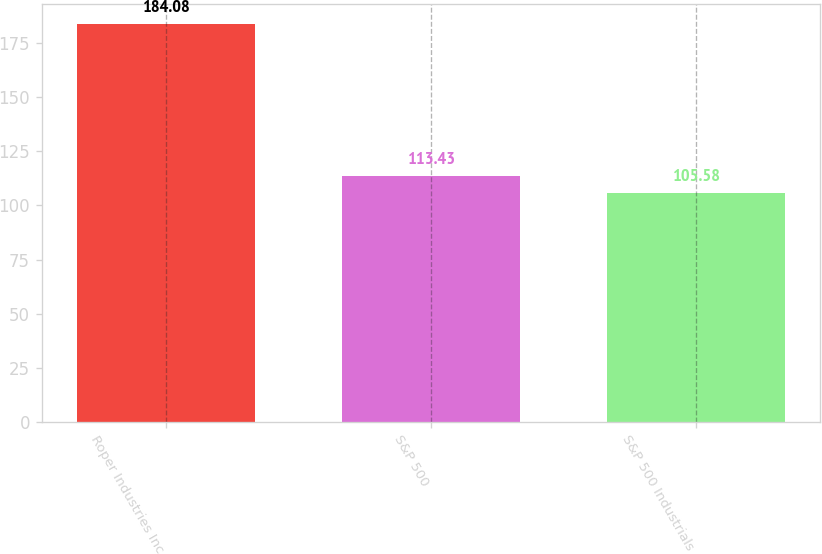Convert chart to OTSL. <chart><loc_0><loc_0><loc_500><loc_500><bar_chart><fcel>Roper Industries Inc<fcel>S&P 500<fcel>S&P 500 Industrials<nl><fcel>184.08<fcel>113.43<fcel>105.58<nl></chart> 